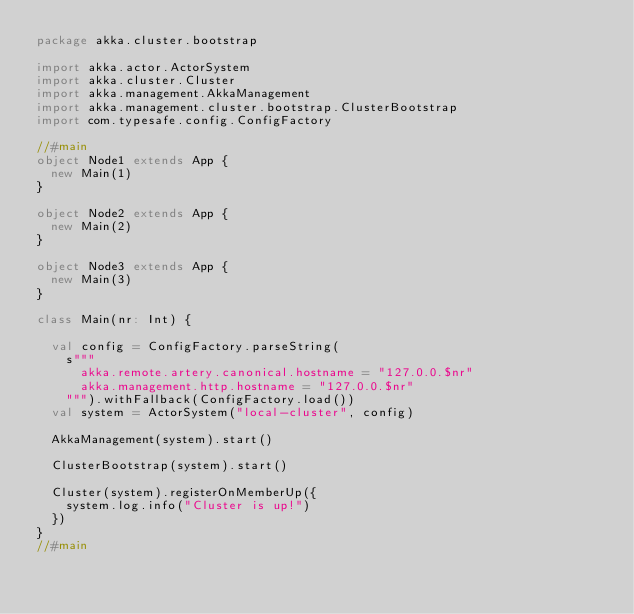Convert code to text. <code><loc_0><loc_0><loc_500><loc_500><_Scala_>package akka.cluster.bootstrap

import akka.actor.ActorSystem
import akka.cluster.Cluster
import akka.management.AkkaManagement
import akka.management.cluster.bootstrap.ClusterBootstrap
import com.typesafe.config.ConfigFactory

//#main
object Node1 extends App {
  new Main(1)
}

object Node2 extends App {
  new Main(2)
}

object Node3 extends App {
  new Main(3)
}

class Main(nr: Int) {

  val config = ConfigFactory.parseString(
    s"""
      akka.remote.artery.canonical.hostname = "127.0.0.$nr"
      akka.management.http.hostname = "127.0.0.$nr"
    """).withFallback(ConfigFactory.load())
  val system = ActorSystem("local-cluster", config)

  AkkaManagement(system).start()

  ClusterBootstrap(system).start()

  Cluster(system).registerOnMemberUp({
    system.log.info("Cluster is up!")
  })
}
//#main
</code> 